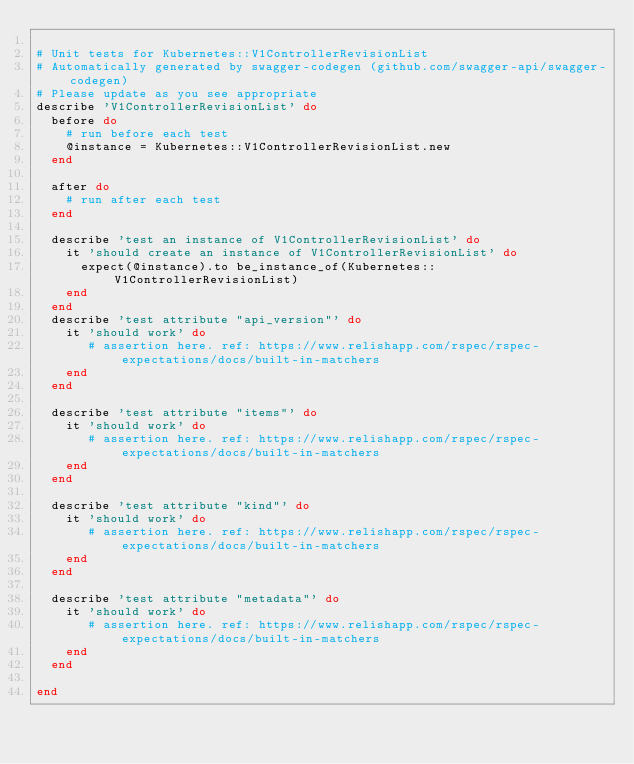<code> <loc_0><loc_0><loc_500><loc_500><_Ruby_>
# Unit tests for Kubernetes::V1ControllerRevisionList
# Automatically generated by swagger-codegen (github.com/swagger-api/swagger-codegen)
# Please update as you see appropriate
describe 'V1ControllerRevisionList' do
  before do
    # run before each test
    @instance = Kubernetes::V1ControllerRevisionList.new
  end

  after do
    # run after each test
  end

  describe 'test an instance of V1ControllerRevisionList' do
    it 'should create an instance of V1ControllerRevisionList' do
      expect(@instance).to be_instance_of(Kubernetes::V1ControllerRevisionList)
    end
  end
  describe 'test attribute "api_version"' do
    it 'should work' do
       # assertion here. ref: https://www.relishapp.com/rspec/rspec-expectations/docs/built-in-matchers
    end
  end

  describe 'test attribute "items"' do
    it 'should work' do
       # assertion here. ref: https://www.relishapp.com/rspec/rspec-expectations/docs/built-in-matchers
    end
  end

  describe 'test attribute "kind"' do
    it 'should work' do
       # assertion here. ref: https://www.relishapp.com/rspec/rspec-expectations/docs/built-in-matchers
    end
  end

  describe 'test attribute "metadata"' do
    it 'should work' do
       # assertion here. ref: https://www.relishapp.com/rspec/rspec-expectations/docs/built-in-matchers
    end
  end

end

</code> 